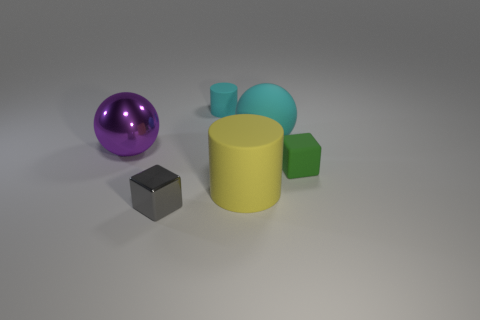Add 3 small yellow matte spheres. How many objects exist? 9 Subtract 1 cylinders. How many cylinders are left? 1 Subtract all yellow cylinders. How many cylinders are left? 1 Subtract all cubes. How many objects are left? 4 Add 6 tiny cyan cylinders. How many tiny cyan cylinders exist? 7 Subtract 0 purple cubes. How many objects are left? 6 Subtract all red balls. Subtract all blue cubes. How many balls are left? 2 Subtract all small cyan things. Subtract all gray metal cubes. How many objects are left? 4 Add 4 cyan rubber balls. How many cyan rubber balls are left? 5 